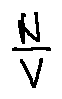Convert formula to latex. <formula><loc_0><loc_0><loc_500><loc_500>\frac { N } { V }</formula> 